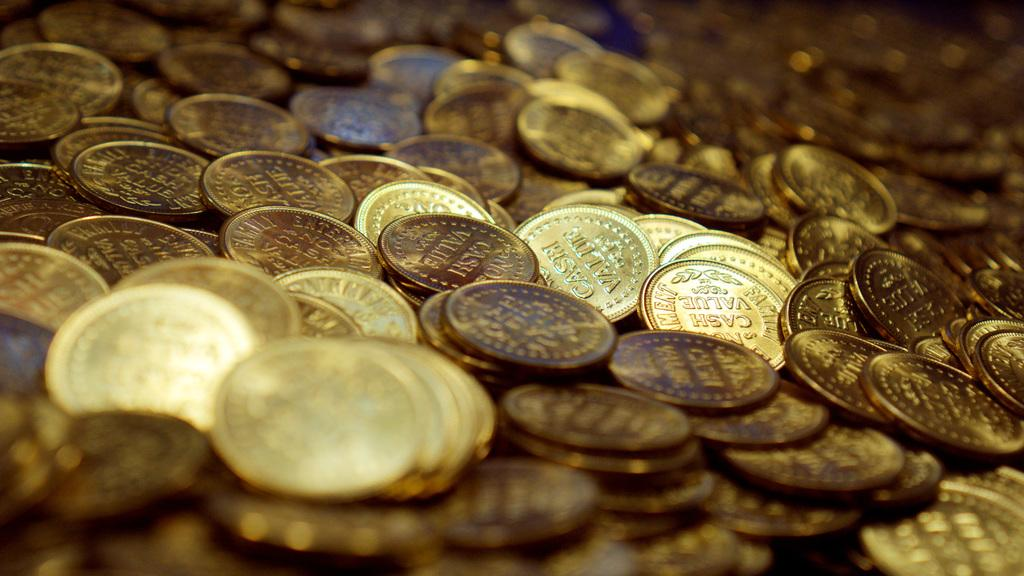Provide a one-sentence caption for the provided image. Several gold-colored coins read "no cash value" on them. 